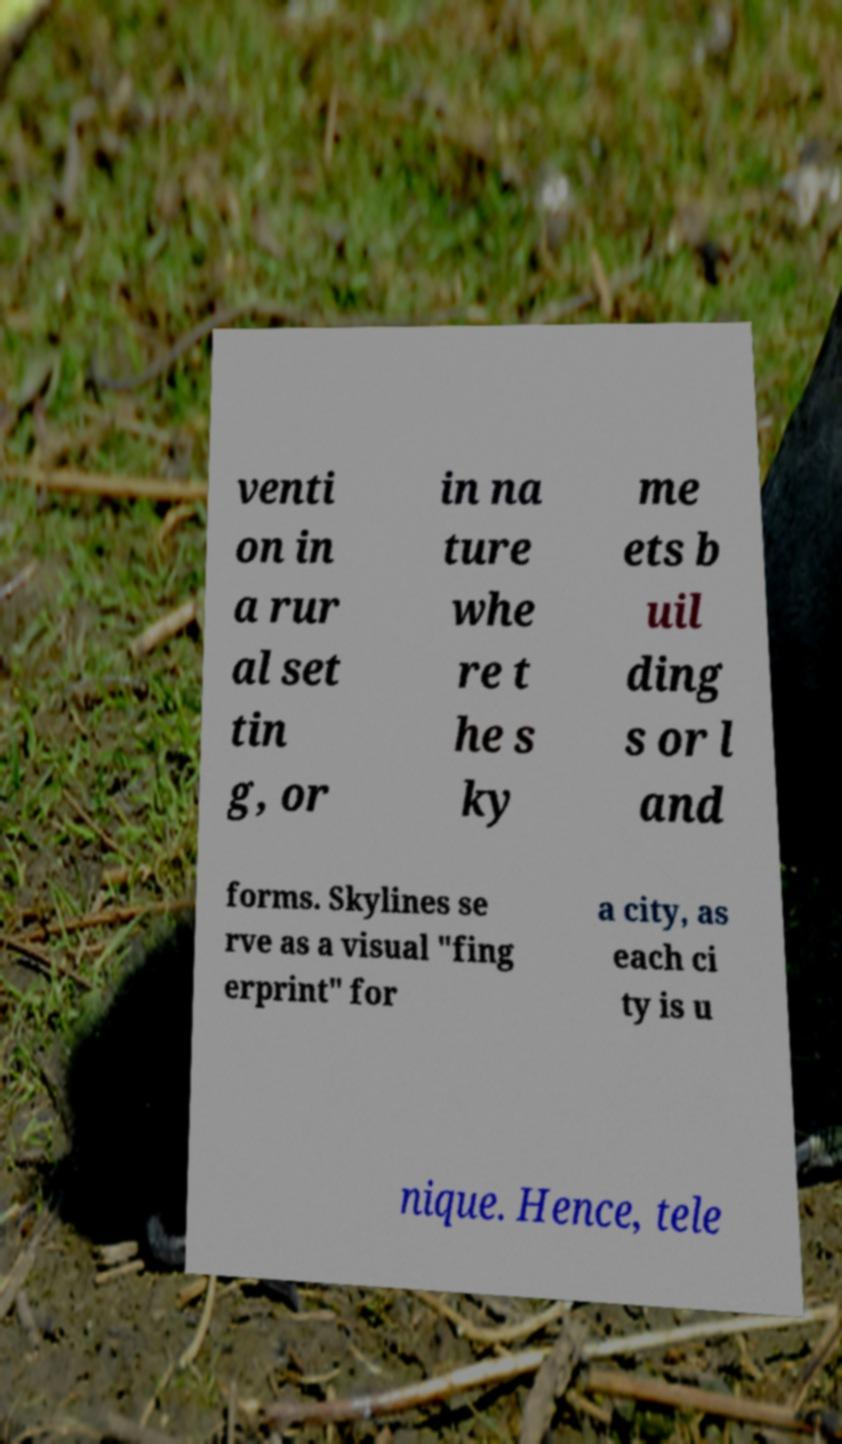For documentation purposes, I need the text within this image transcribed. Could you provide that? venti on in a rur al set tin g, or in na ture whe re t he s ky me ets b uil ding s or l and forms. Skylines se rve as a visual "fing erprint" for a city, as each ci ty is u nique. Hence, tele 